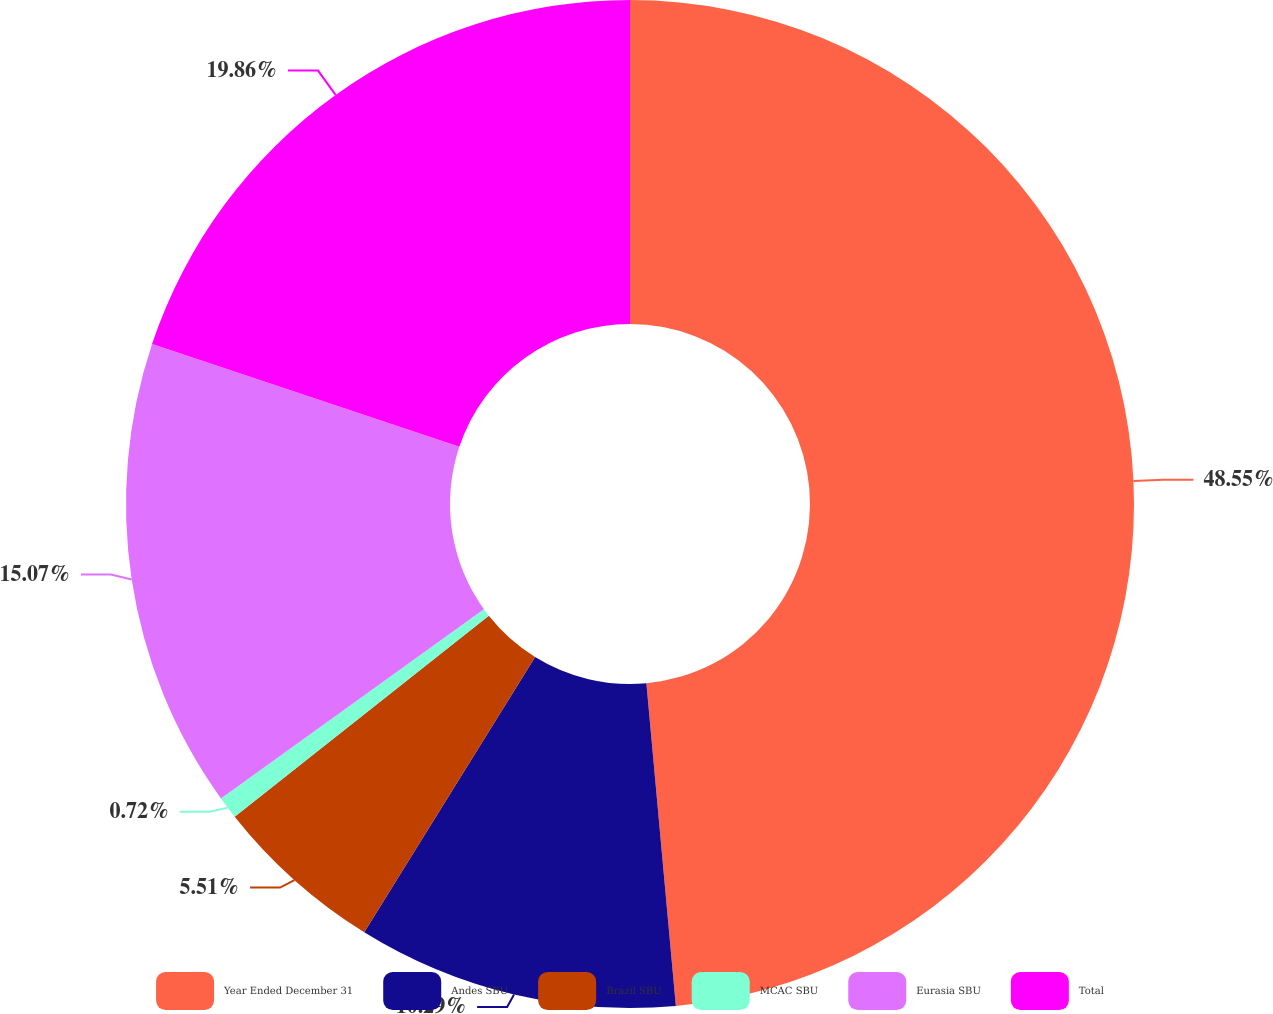<chart> <loc_0><loc_0><loc_500><loc_500><pie_chart><fcel>Year Ended December 31<fcel>Andes SBU<fcel>Brazil SBU<fcel>MCAC SBU<fcel>Eurasia SBU<fcel>Total<nl><fcel>48.55%<fcel>10.29%<fcel>5.51%<fcel>0.72%<fcel>15.07%<fcel>19.86%<nl></chart> 